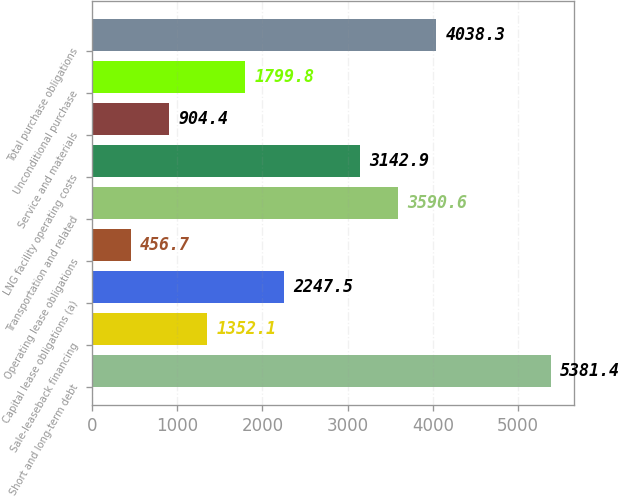<chart> <loc_0><loc_0><loc_500><loc_500><bar_chart><fcel>Short and long-term debt<fcel>Sale-leaseback financing<fcel>Capital lease obligations (a)<fcel>Operating lease obligations<fcel>Transportation and related<fcel>LNG facility operating costs<fcel>Service and materials<fcel>Unconditional purchase<fcel>Total purchase obligations<nl><fcel>5381.4<fcel>1352.1<fcel>2247.5<fcel>456.7<fcel>3590.6<fcel>3142.9<fcel>904.4<fcel>1799.8<fcel>4038.3<nl></chart> 